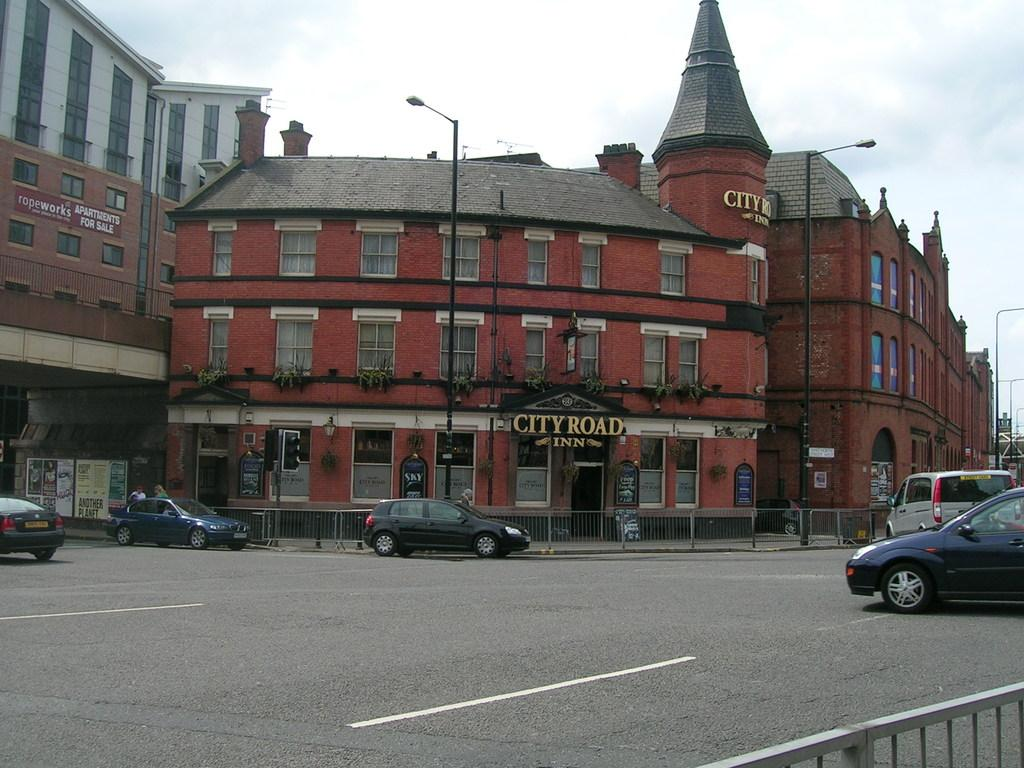What type of structures can be seen in the image? There are buildings in the image. What type of lighting is present in the image? There are street lamps in the image. What type of barrier is visible in the image? There is a fence in the image. What type of signage is present in the image? There is a banner in the image. What type of vehicles are present in the image? There are cars in the image. What is visible at the top of the image? The sky is visible at the top of the image. How many bikes are leaning against the fence in the image? There are no bikes present in the image. What type of canvas is used to create the banner in the image? There is no canvas mentioned in the image, as it only states that there is a banner present. 